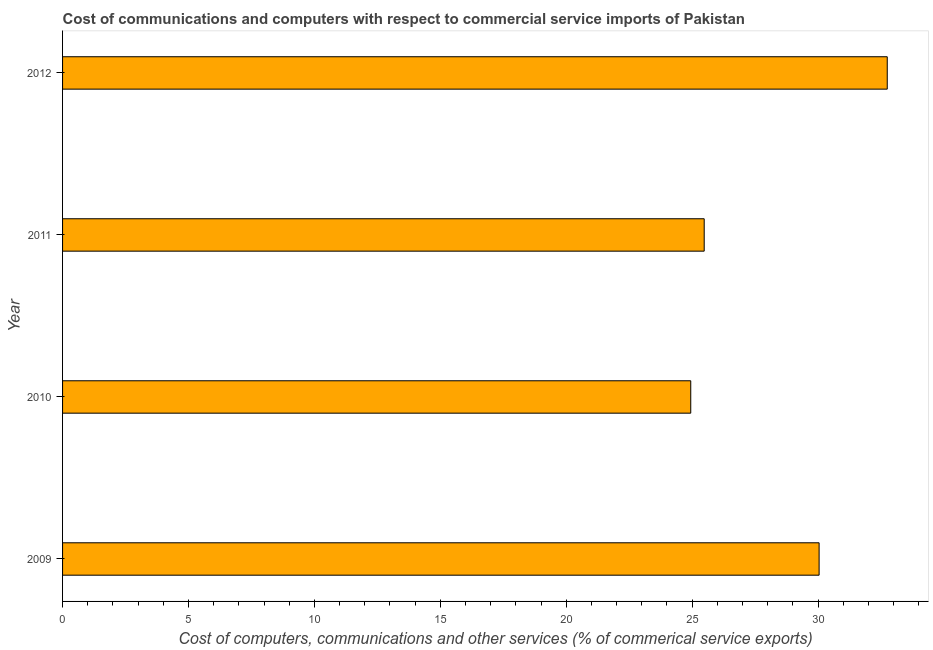What is the title of the graph?
Your response must be concise. Cost of communications and computers with respect to commercial service imports of Pakistan. What is the label or title of the X-axis?
Your response must be concise. Cost of computers, communications and other services (% of commerical service exports). What is the cost of communications in 2011?
Ensure brevity in your answer.  25.48. Across all years, what is the maximum cost of communications?
Your answer should be very brief. 32.75. Across all years, what is the minimum cost of communications?
Provide a short and direct response. 24.95. In which year was the cost of communications minimum?
Make the answer very short. 2010. What is the sum of the cost of communications?
Provide a succinct answer. 113.22. What is the difference between the cost of communications in 2009 and 2010?
Your response must be concise. 5.1. What is the average cost of communications per year?
Offer a very short reply. 28.3. What is the median cost of communications?
Offer a very short reply. 27.76. Do a majority of the years between 2010 and 2012 (inclusive) have  computer and other services greater than 16 %?
Your answer should be compact. Yes. What is the ratio of the  computer and other services in 2009 to that in 2010?
Your response must be concise. 1.2. What is the difference between the highest and the second highest cost of communications?
Offer a very short reply. 2.71. What is the difference between the highest and the lowest cost of communications?
Offer a very short reply. 7.8. Are all the bars in the graph horizontal?
Offer a very short reply. Yes. How many years are there in the graph?
Provide a short and direct response. 4. What is the difference between two consecutive major ticks on the X-axis?
Provide a short and direct response. 5. Are the values on the major ticks of X-axis written in scientific E-notation?
Give a very brief answer. No. What is the Cost of computers, communications and other services (% of commerical service exports) in 2009?
Offer a terse response. 30.04. What is the Cost of computers, communications and other services (% of commerical service exports) in 2010?
Offer a very short reply. 24.95. What is the Cost of computers, communications and other services (% of commerical service exports) of 2011?
Give a very brief answer. 25.48. What is the Cost of computers, communications and other services (% of commerical service exports) in 2012?
Keep it short and to the point. 32.75. What is the difference between the Cost of computers, communications and other services (% of commerical service exports) in 2009 and 2010?
Give a very brief answer. 5.1. What is the difference between the Cost of computers, communications and other services (% of commerical service exports) in 2009 and 2011?
Your response must be concise. 4.56. What is the difference between the Cost of computers, communications and other services (% of commerical service exports) in 2009 and 2012?
Offer a terse response. -2.71. What is the difference between the Cost of computers, communications and other services (% of commerical service exports) in 2010 and 2011?
Offer a terse response. -0.53. What is the difference between the Cost of computers, communications and other services (% of commerical service exports) in 2010 and 2012?
Your answer should be compact. -7.8. What is the difference between the Cost of computers, communications and other services (% of commerical service exports) in 2011 and 2012?
Your response must be concise. -7.27. What is the ratio of the Cost of computers, communications and other services (% of commerical service exports) in 2009 to that in 2010?
Offer a terse response. 1.2. What is the ratio of the Cost of computers, communications and other services (% of commerical service exports) in 2009 to that in 2011?
Keep it short and to the point. 1.18. What is the ratio of the Cost of computers, communications and other services (% of commerical service exports) in 2009 to that in 2012?
Give a very brief answer. 0.92. What is the ratio of the Cost of computers, communications and other services (% of commerical service exports) in 2010 to that in 2012?
Your answer should be very brief. 0.76. What is the ratio of the Cost of computers, communications and other services (% of commerical service exports) in 2011 to that in 2012?
Your answer should be compact. 0.78. 